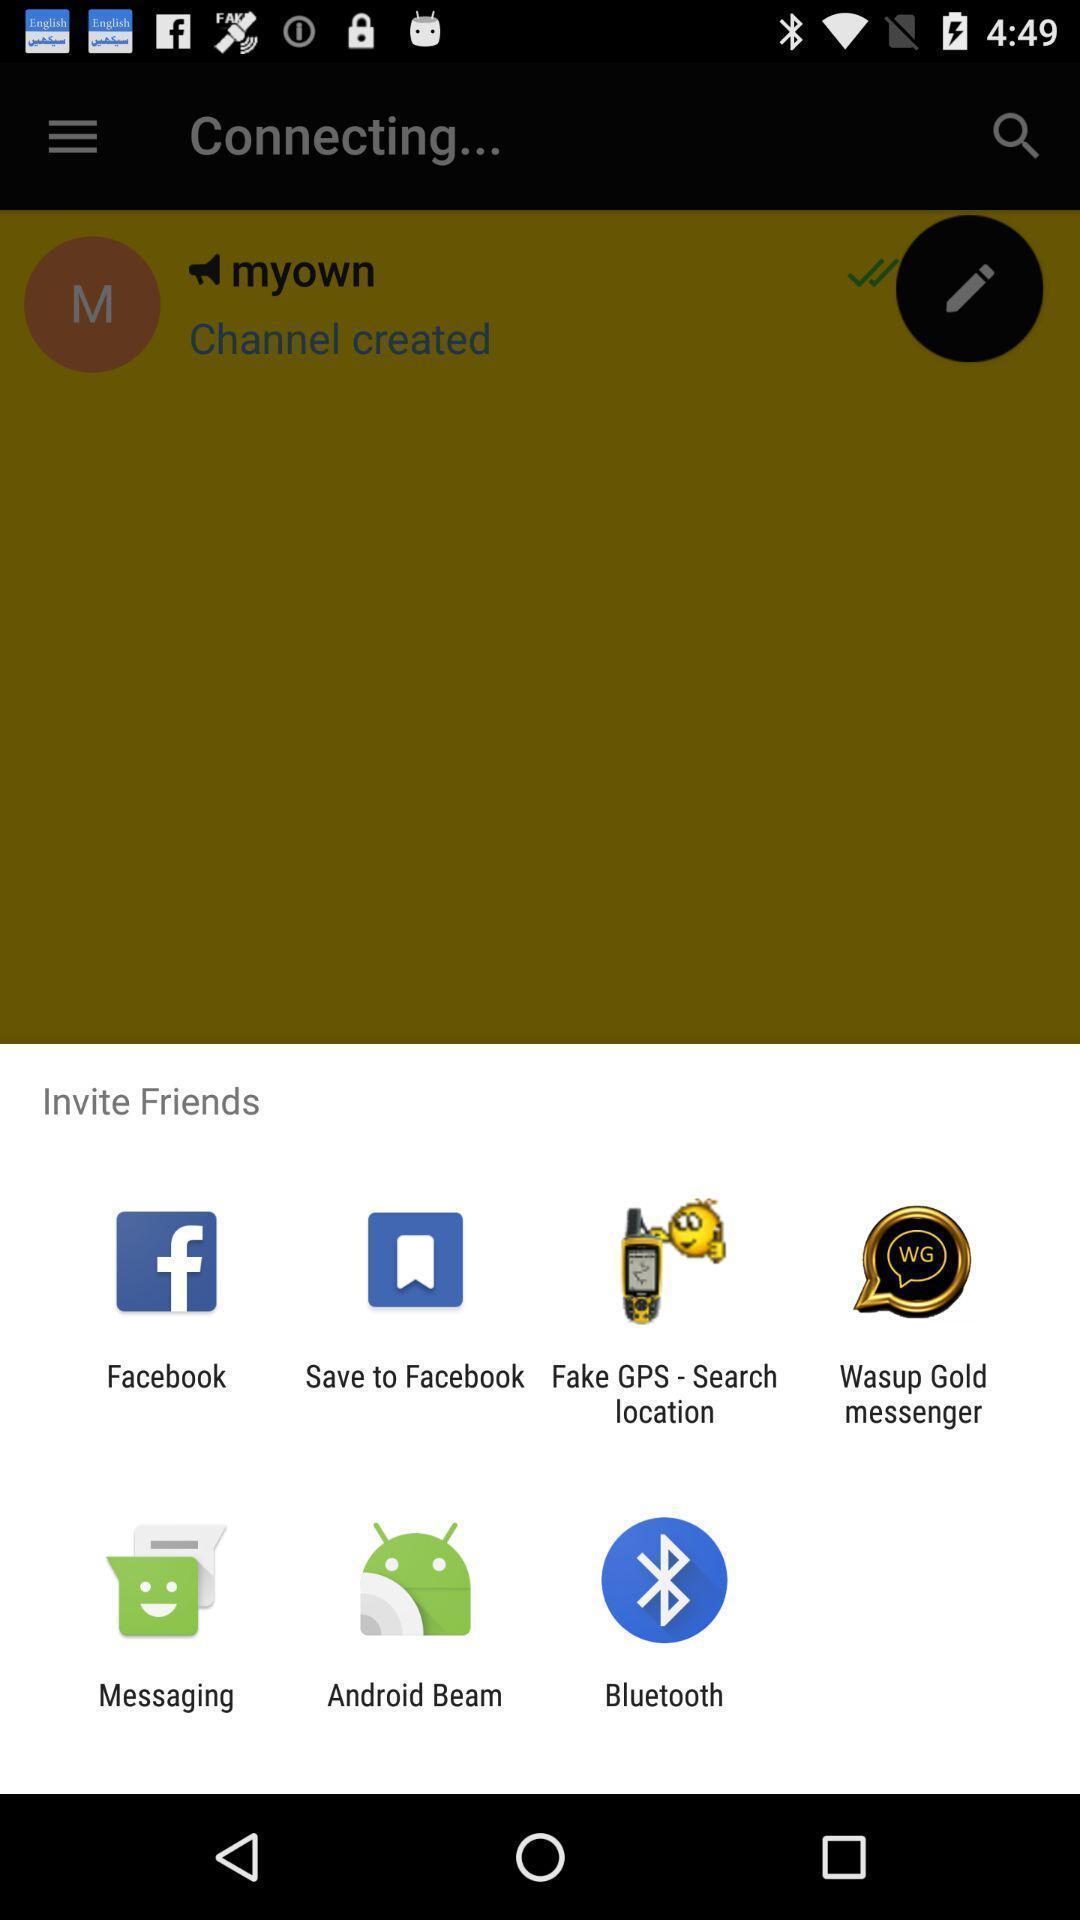Tell me about the visual elements in this screen capture. Pop up showing different inviting options. 